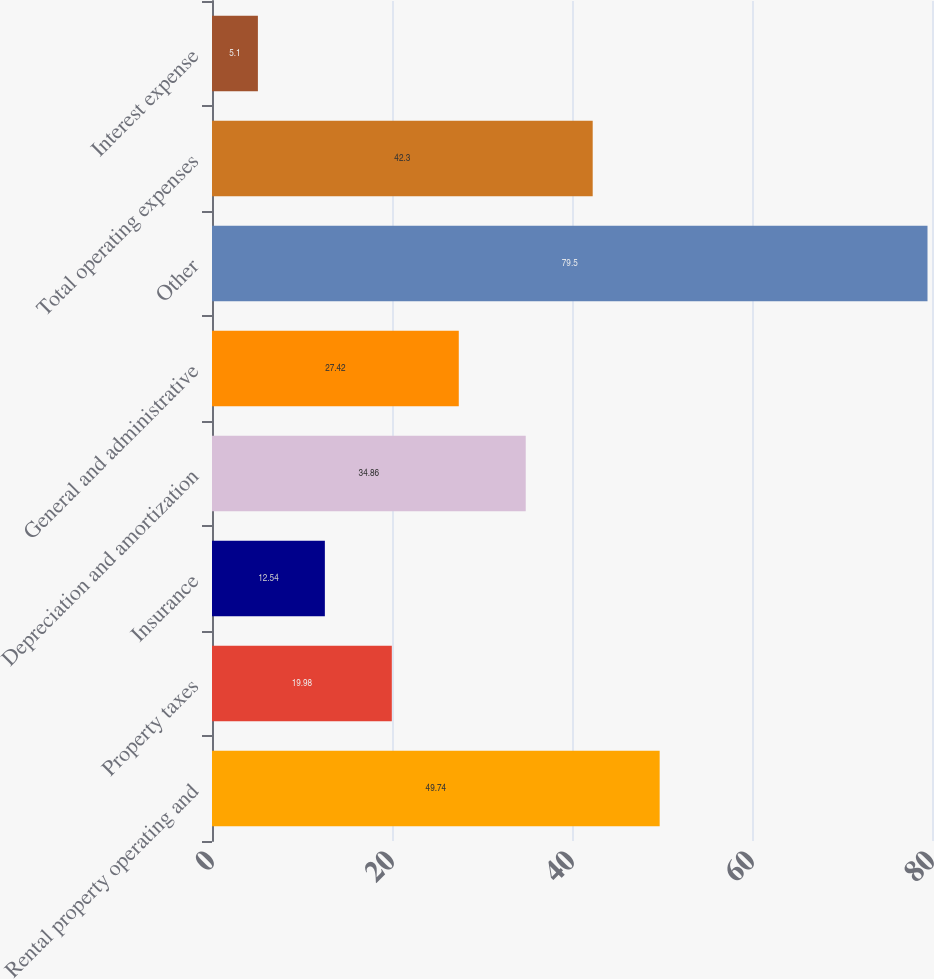<chart> <loc_0><loc_0><loc_500><loc_500><bar_chart><fcel>Rental property operating and<fcel>Property taxes<fcel>Insurance<fcel>Depreciation and amortization<fcel>General and administrative<fcel>Other<fcel>Total operating expenses<fcel>Interest expense<nl><fcel>49.74<fcel>19.98<fcel>12.54<fcel>34.86<fcel>27.42<fcel>79.5<fcel>42.3<fcel>5.1<nl></chart> 